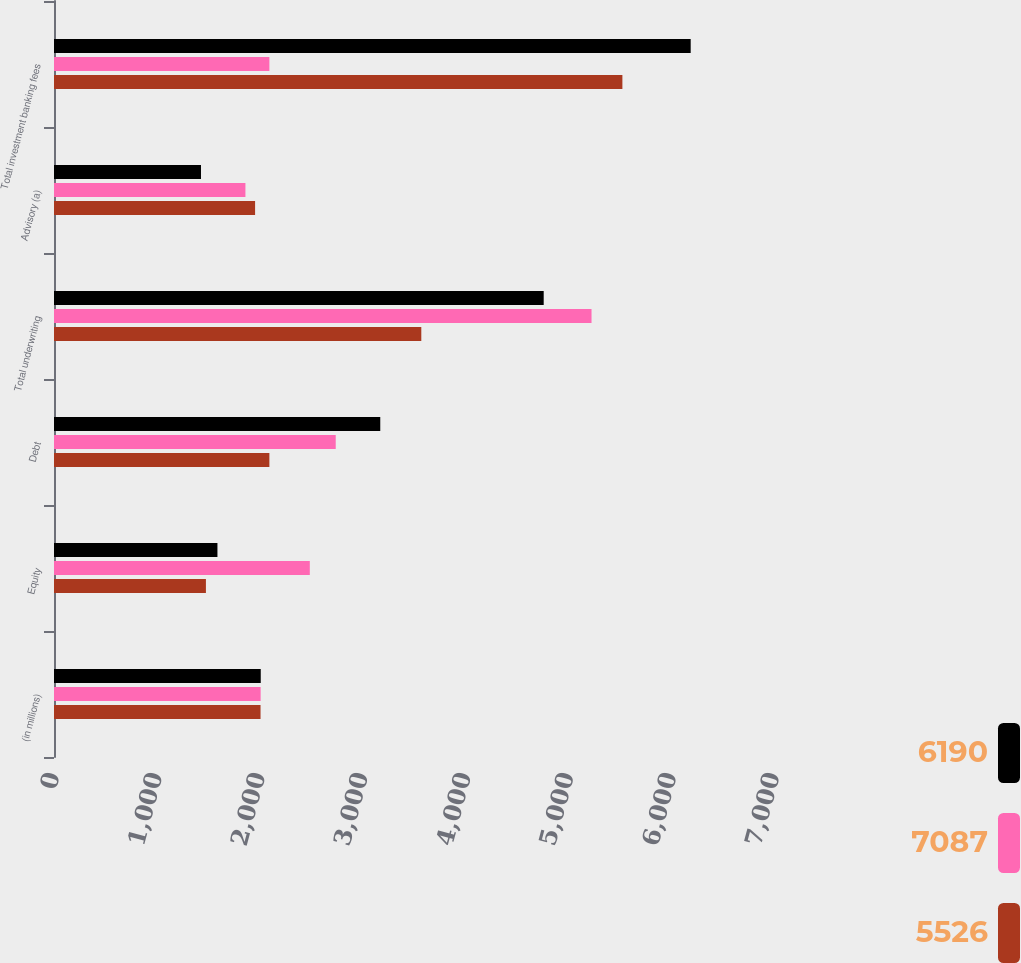<chart> <loc_0><loc_0><loc_500><loc_500><stacked_bar_chart><ecel><fcel>(in millions)<fcel>Equity<fcel>Debt<fcel>Total underwriting<fcel>Advisory (a)<fcel>Total investment banking fees<nl><fcel>6190<fcel>2010<fcel>1589<fcel>3172<fcel>4761<fcel>1429<fcel>6190<nl><fcel>7087<fcel>2009<fcel>2487<fcel>2739<fcel>5226<fcel>1861<fcel>2094<nl><fcel>5526<fcel>2008<fcel>1477<fcel>2094<fcel>3571<fcel>1955<fcel>5526<nl></chart> 